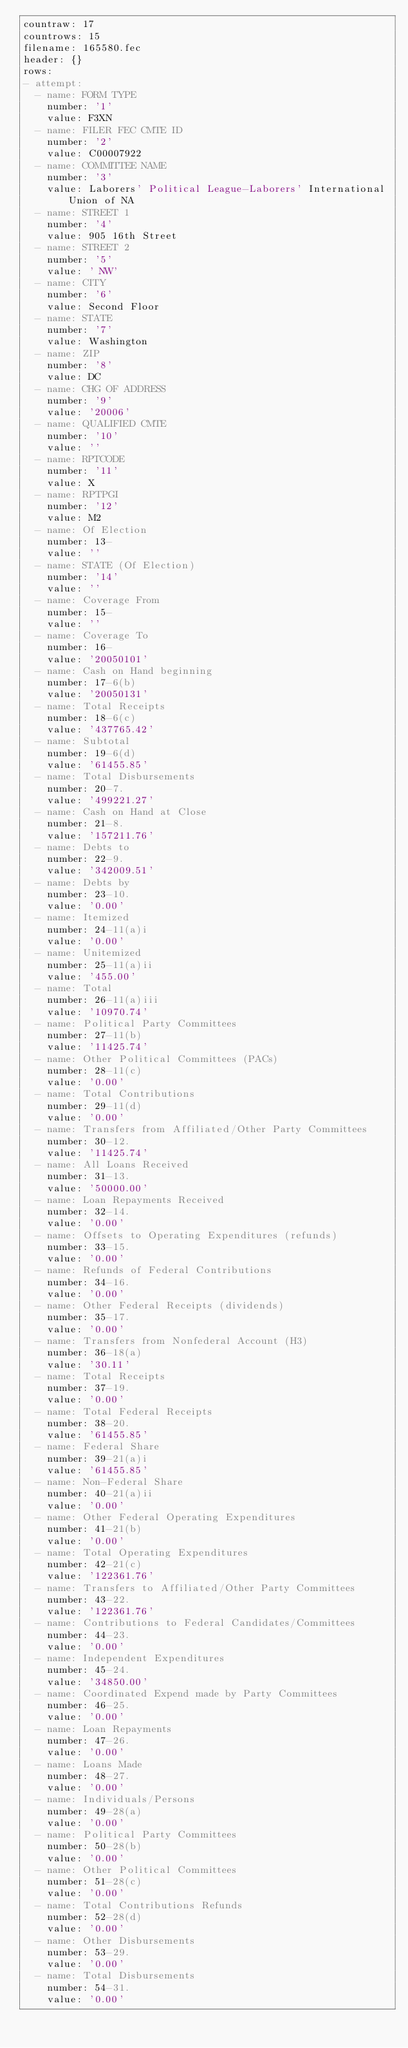Convert code to text. <code><loc_0><loc_0><loc_500><loc_500><_YAML_>countraw: 17
countrows: 15
filename: 165580.fec
header: {}
rows:
- attempt:
  - name: FORM TYPE
    number: '1'
    value: F3XN
  - name: FILER FEC CMTE ID
    number: '2'
    value: C00007922
  - name: COMMITTEE NAME
    number: '3'
    value: Laborers' Political League-Laborers' International Union of NA
  - name: STREET 1
    number: '4'
    value: 905 16th Street
  - name: STREET 2
    number: '5'
    value: ' NW'
  - name: CITY
    number: '6'
    value: Second Floor
  - name: STATE
    number: '7'
    value: Washington
  - name: ZIP
    number: '8'
    value: DC
  - name: CHG OF ADDRESS
    number: '9'
    value: '20006'
  - name: QUALIFIED CMTE
    number: '10'
    value: ''
  - name: RPTCODE
    number: '11'
    value: X
  - name: RPTPGI
    number: '12'
    value: M2
  - name: Of Election
    number: 13-
    value: ''
  - name: STATE (Of Election)
    number: '14'
    value: ''
  - name: Coverage From
    number: 15-
    value: ''
  - name: Coverage To
    number: 16-
    value: '20050101'
  - name: Cash on Hand beginning
    number: 17-6(b)
    value: '20050131'
  - name: Total Receipts
    number: 18-6(c)
    value: '437765.42'
  - name: Subtotal
    number: 19-6(d)
    value: '61455.85'
  - name: Total Disbursements
    number: 20-7.
    value: '499221.27'
  - name: Cash on Hand at Close
    number: 21-8.
    value: '157211.76'
  - name: Debts to
    number: 22-9.
    value: '342009.51'
  - name: Debts by
    number: 23-10.
    value: '0.00'
  - name: Itemized
    number: 24-11(a)i
    value: '0.00'
  - name: Unitemized
    number: 25-11(a)ii
    value: '455.00'
  - name: Total
    number: 26-11(a)iii
    value: '10970.74'
  - name: Political Party Committees
    number: 27-11(b)
    value: '11425.74'
  - name: Other Political Committees (PACs)
    number: 28-11(c)
    value: '0.00'
  - name: Total Contributions
    number: 29-11(d)
    value: '0.00'
  - name: Transfers from Affiliated/Other Party Committees
    number: 30-12.
    value: '11425.74'
  - name: All Loans Received
    number: 31-13.
    value: '50000.00'
  - name: Loan Repayments Received
    number: 32-14.
    value: '0.00'
  - name: Offsets to Operating Expenditures (refunds)
    number: 33-15.
    value: '0.00'
  - name: Refunds of Federal Contributions
    number: 34-16.
    value: '0.00'
  - name: Other Federal Receipts (dividends)
    number: 35-17.
    value: '0.00'
  - name: Transfers from Nonfederal Account (H3)
    number: 36-18(a)
    value: '30.11'
  - name: Total Receipts
    number: 37-19.
    value: '0.00'
  - name: Total Federal Receipts
    number: 38-20.
    value: '61455.85'
  - name: Federal Share
    number: 39-21(a)i
    value: '61455.85'
  - name: Non-Federal Share
    number: 40-21(a)ii
    value: '0.00'
  - name: Other Federal Operating Expenditures
    number: 41-21(b)
    value: '0.00'
  - name: Total Operating Expenditures
    number: 42-21(c)
    value: '122361.76'
  - name: Transfers to Affiliated/Other Party Committees
    number: 43-22.
    value: '122361.76'
  - name: Contributions to Federal Candidates/Committees
    number: 44-23.
    value: '0.00'
  - name: Independent Expenditures
    number: 45-24.
    value: '34850.00'
  - name: Coordinated Expend made by Party Committees
    number: 46-25.
    value: '0.00'
  - name: Loan Repayments
    number: 47-26.
    value: '0.00'
  - name: Loans Made
    number: 48-27.
    value: '0.00'
  - name: Individuals/Persons
    number: 49-28(a)
    value: '0.00'
  - name: Political Party Committees
    number: 50-28(b)
    value: '0.00'
  - name: Other Political Committees
    number: 51-28(c)
    value: '0.00'
  - name: Total Contributions Refunds
    number: 52-28(d)
    value: '0.00'
  - name: Other Disbursements
    number: 53-29.
    value: '0.00'
  - name: Total Disbursements
    number: 54-31.
    value: '0.00'</code> 